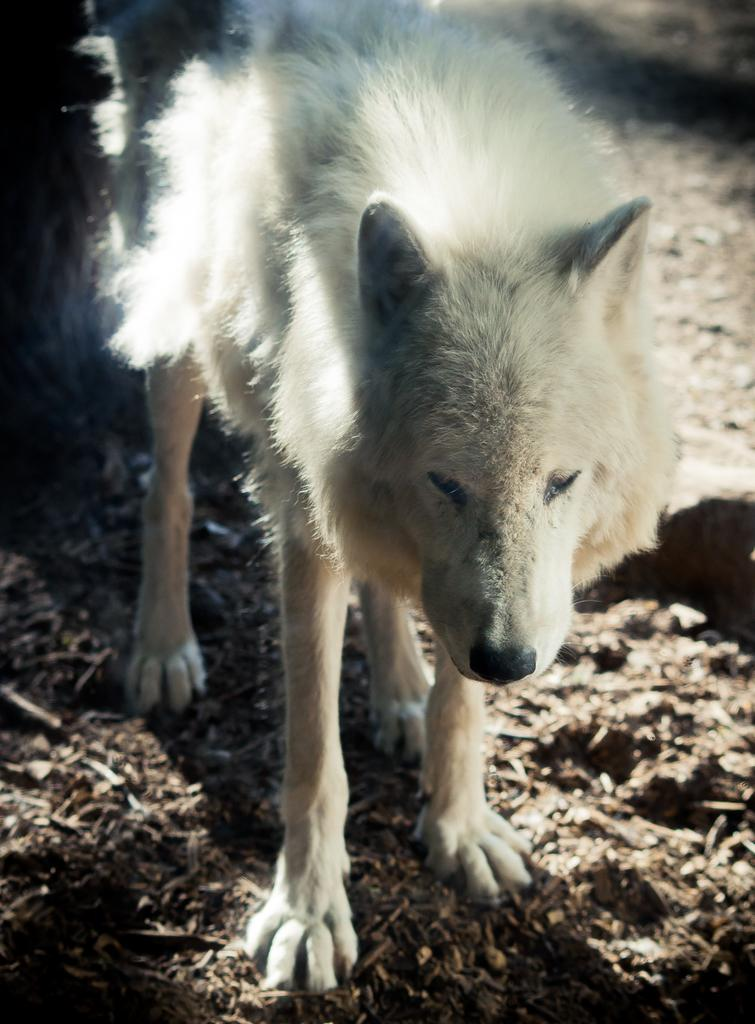What type of animal is in the picture? There is a wolf dog in the picture. What can be seen at the bottom of the image? The bottom of the image contains soil. What type of agreement is being signed by the wolf dog in the image? There is no agreement being signed in the image, as it features a wolf dog and soil. What color are the tomatoes on the wrist of the wolf dog in the image? There are no tomatoes or any reference to a wrist in the image, as it only features a wolf dog and soil. 